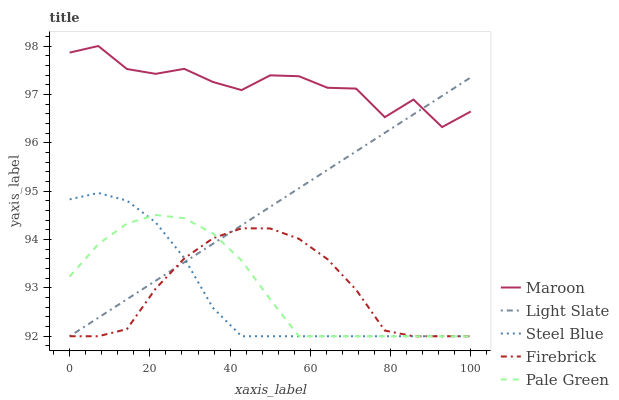Does Steel Blue have the minimum area under the curve?
Answer yes or no. Yes. Does Maroon have the maximum area under the curve?
Answer yes or no. Yes. Does Firebrick have the minimum area under the curve?
Answer yes or no. No. Does Firebrick have the maximum area under the curve?
Answer yes or no. No. Is Light Slate the smoothest?
Answer yes or no. Yes. Is Maroon the roughest?
Answer yes or no. Yes. Is Firebrick the smoothest?
Answer yes or no. No. Is Firebrick the roughest?
Answer yes or no. No. Does Light Slate have the lowest value?
Answer yes or no. Yes. Does Maroon have the lowest value?
Answer yes or no. No. Does Maroon have the highest value?
Answer yes or no. Yes. Does Pale Green have the highest value?
Answer yes or no. No. Is Pale Green less than Maroon?
Answer yes or no. Yes. Is Maroon greater than Pale Green?
Answer yes or no. Yes. Does Light Slate intersect Steel Blue?
Answer yes or no. Yes. Is Light Slate less than Steel Blue?
Answer yes or no. No. Is Light Slate greater than Steel Blue?
Answer yes or no. No. Does Pale Green intersect Maroon?
Answer yes or no. No. 